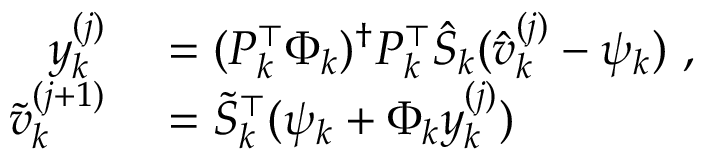Convert formula to latex. <formula><loc_0><loc_0><loc_500><loc_500>\begin{array} { r l } { y _ { k } ^ { ( j ) } } & = ( P _ { k } ^ { \top } \Phi _ { k } ) ^ { \dagger } P _ { k } ^ { \top } \hat { S } _ { k } ( \hat { v } _ { k } ^ { ( j ) } - \psi _ { k } ) , } \\ { \tilde { v } _ { k } ^ { ( j + 1 ) } } & = \tilde { S } _ { k } ^ { \top } ( \psi _ { k } + \Phi _ { k } y _ { k } ^ { ( j ) } ) } \end{array}</formula> 